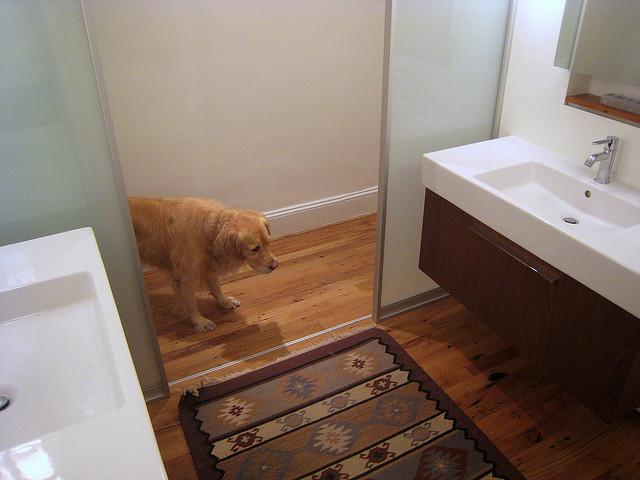What color is the dog standing inside of the doorway to the bathroom?

Choices:
A) gray
B) chocolate
C) golden
D) black golden 